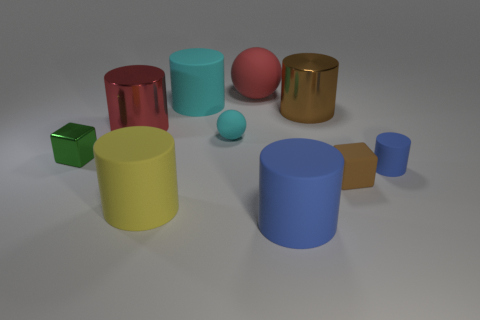Subtract 1 cylinders. How many cylinders are left? 5 Subtract all cyan cylinders. How many cylinders are left? 5 Subtract all yellow matte cylinders. How many cylinders are left? 5 Subtract all purple cylinders. Subtract all blue spheres. How many cylinders are left? 6 Subtract all cylinders. How many objects are left? 4 Subtract 1 red cylinders. How many objects are left? 9 Subtract all green cylinders. Subtract all big red things. How many objects are left? 8 Add 6 blue matte objects. How many blue matte objects are left? 8 Add 4 tiny blue shiny cylinders. How many tiny blue shiny cylinders exist? 4 